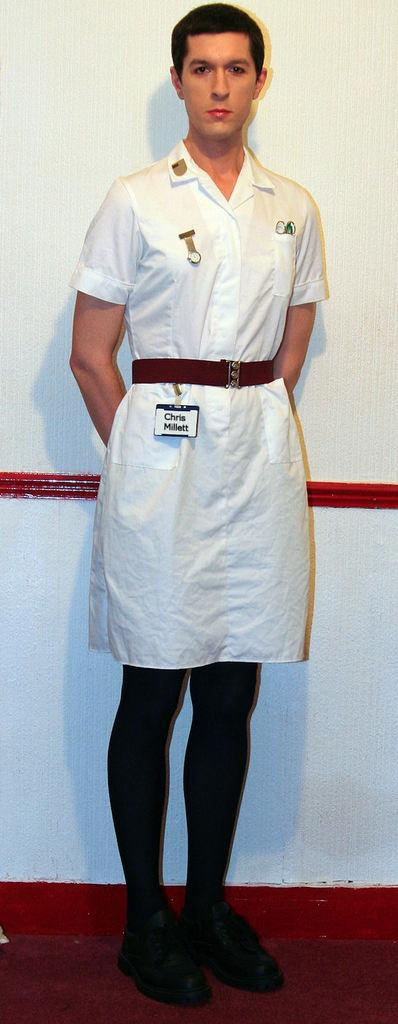<image>
Render a clear and concise summary of the photo. Man wearing a top that says the words "Chris Millett". 